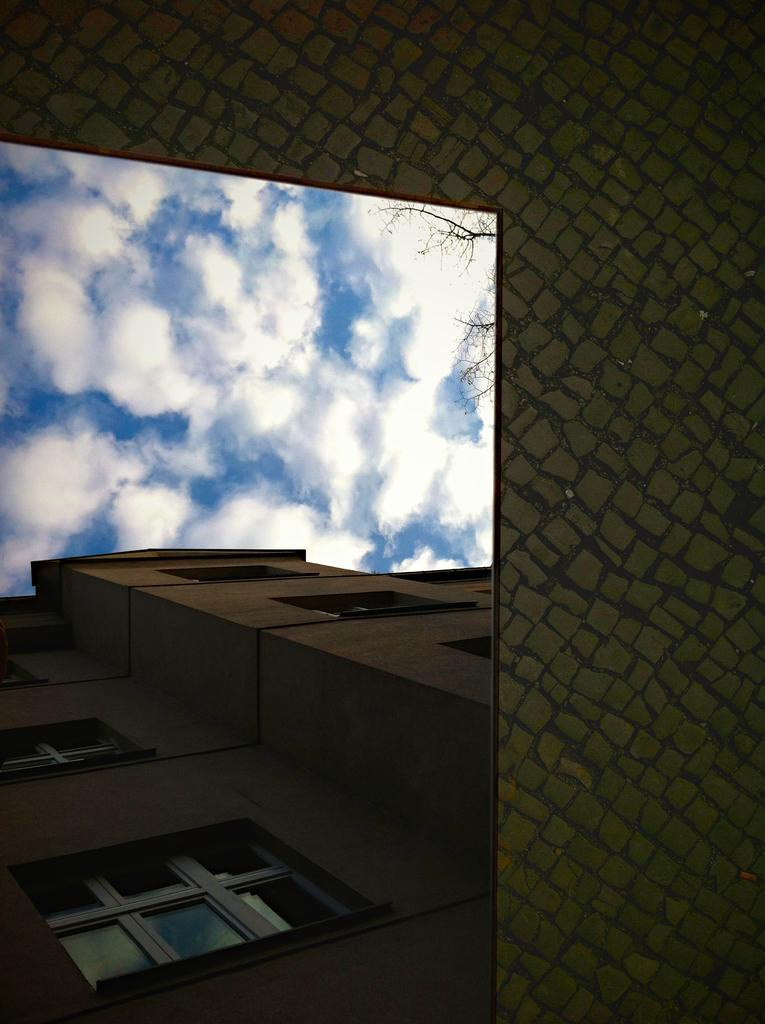What structure is located on the left side of the image? There is a building with windows on the left side of the image. What can be seen in the background of the image? The sky is visible in the background of the image. What is on the right side of the image? There is a wall on the right side of the image. How many cars are parked near the ocean in the image? There is no ocean or cars present in the image. What riddle can be solved by looking at the image? There is no riddle associated with the image. 